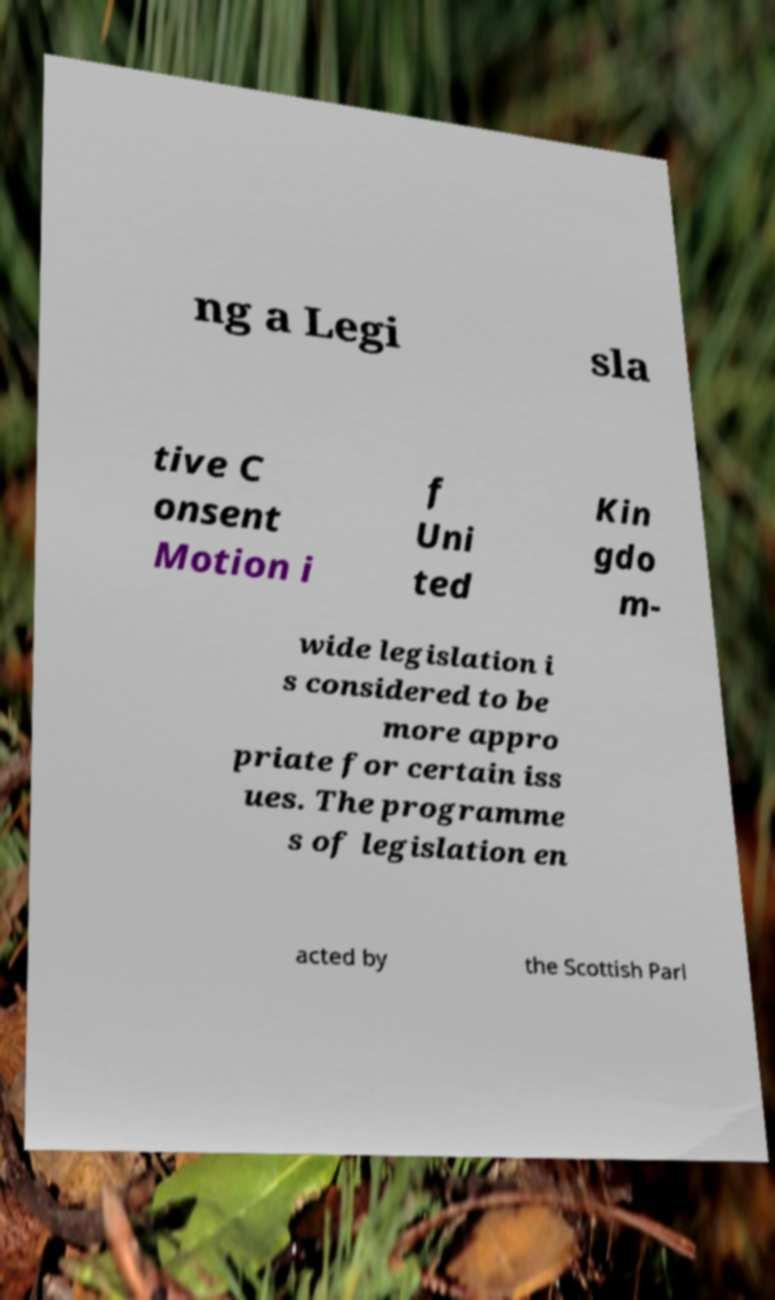There's text embedded in this image that I need extracted. Can you transcribe it verbatim? ng a Legi sla tive C onsent Motion i f Uni ted Kin gdo m- wide legislation i s considered to be more appro priate for certain iss ues. The programme s of legislation en acted by the Scottish Parl 